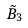<formula> <loc_0><loc_0><loc_500><loc_500>\tilde { B } _ { 3 }</formula> 